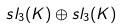<formula> <loc_0><loc_0><loc_500><loc_500>s l _ { 3 } ( K ) \oplus s l _ { 3 } ( K )</formula> 